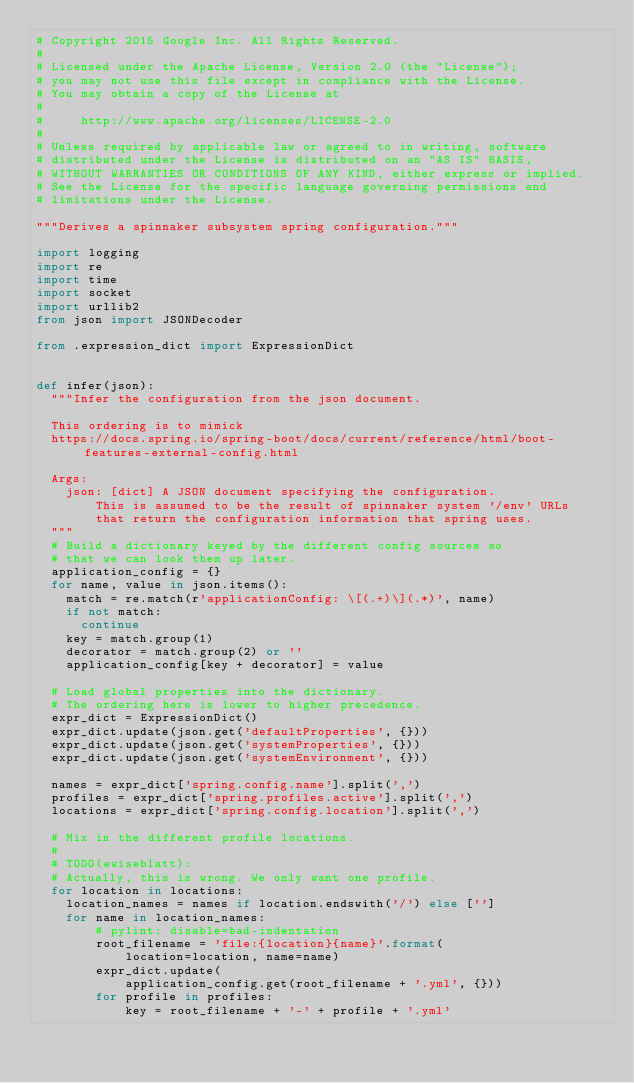<code> <loc_0><loc_0><loc_500><loc_500><_Python_># Copyright 2015 Google Inc. All Rights Reserved.
#
# Licensed under the Apache License, Version 2.0 (the "License");
# you may not use this file except in compliance with the License.
# You may obtain a copy of the License at
#
#     http://www.apache.org/licenses/LICENSE-2.0
#
# Unless required by applicable law or agreed to in writing, software
# distributed under the License is distributed on an "AS IS" BASIS,
# WITHOUT WARRANTIES OR CONDITIONS OF ANY KIND, either express or implied.
# See the License for the specific language governing permissions and
# limitations under the License.

"""Derives a spinnaker subsystem spring configuration."""

import logging
import re
import time
import socket
import urllib2
from json import JSONDecoder

from .expression_dict import ExpressionDict


def infer(json):
  """Infer the configuration from the json document.

  This ordering is to mimick
  https://docs.spring.io/spring-boot/docs/current/reference/html/boot-features-external-config.html

  Args:
    json: [dict] A JSON document specifying the configuration.
        This is assumed to be the result of spinnaker system '/env' URLs
        that return the configuration information that spring uses.
  """
  # Build a dictionary keyed by the different config sources so
  # that we can look them up later.
  application_config = {}
  for name, value in json.items():
    match = re.match(r'applicationConfig: \[(.+)\](.*)', name)
    if not match:
      continue
    key = match.group(1)
    decorator = match.group(2) or ''
    application_config[key + decorator] = value

  # Load global properties into the dictionary.
  # The ordering here is lower to higher precedence.
  expr_dict = ExpressionDict()
  expr_dict.update(json.get('defaultProperties', {}))
  expr_dict.update(json.get('systemProperties', {}))
  expr_dict.update(json.get('systemEnvironment', {}))

  names = expr_dict['spring.config.name'].split(',')
  profiles = expr_dict['spring.profiles.active'].split(',')
  locations = expr_dict['spring.config.location'].split(',')

  # Mix in the different profile locations.
  #
  # TODO(ewiseblatt):
  # Actually, this is wrong. We only want one profile.
  for location in locations:
    location_names = names if location.endswith('/') else ['']
    for name in location_names:
        # pylint: disable=bad-indentation
        root_filename = 'file:{location}{name}'.format(
            location=location, name=name)
        expr_dict.update(
            application_config.get(root_filename + '.yml', {}))
        for profile in profiles:
            key = root_filename + '-' + profile + '.yml'</code> 